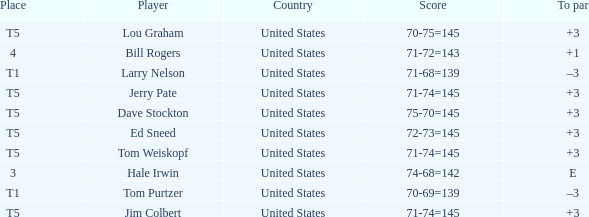Could you parse the entire table? {'header': ['Place', 'Player', 'Country', 'Score', 'To par'], 'rows': [['T5', 'Lou Graham', 'United States', '70-75=145', '+3'], ['4', 'Bill Rogers', 'United States', '71-72=143', '+1'], ['T1', 'Larry Nelson', 'United States', '71-68=139', '–3'], ['T5', 'Jerry Pate', 'United States', '71-74=145', '+3'], ['T5', 'Dave Stockton', 'United States', '75-70=145', '+3'], ['T5', 'Ed Sneed', 'United States', '72-73=145', '+3'], ['T5', 'Tom Weiskopf', 'United States', '71-74=145', '+3'], ['3', 'Hale Irwin', 'United States', '74-68=142', 'E'], ['T1', 'Tom Purtzer', 'United States', '70-69=139', '–3'], ['T5', 'Jim Colbert', 'United States', '71-74=145', '+3']]} What is the country of player ed sneed with a to par of +3? United States. 